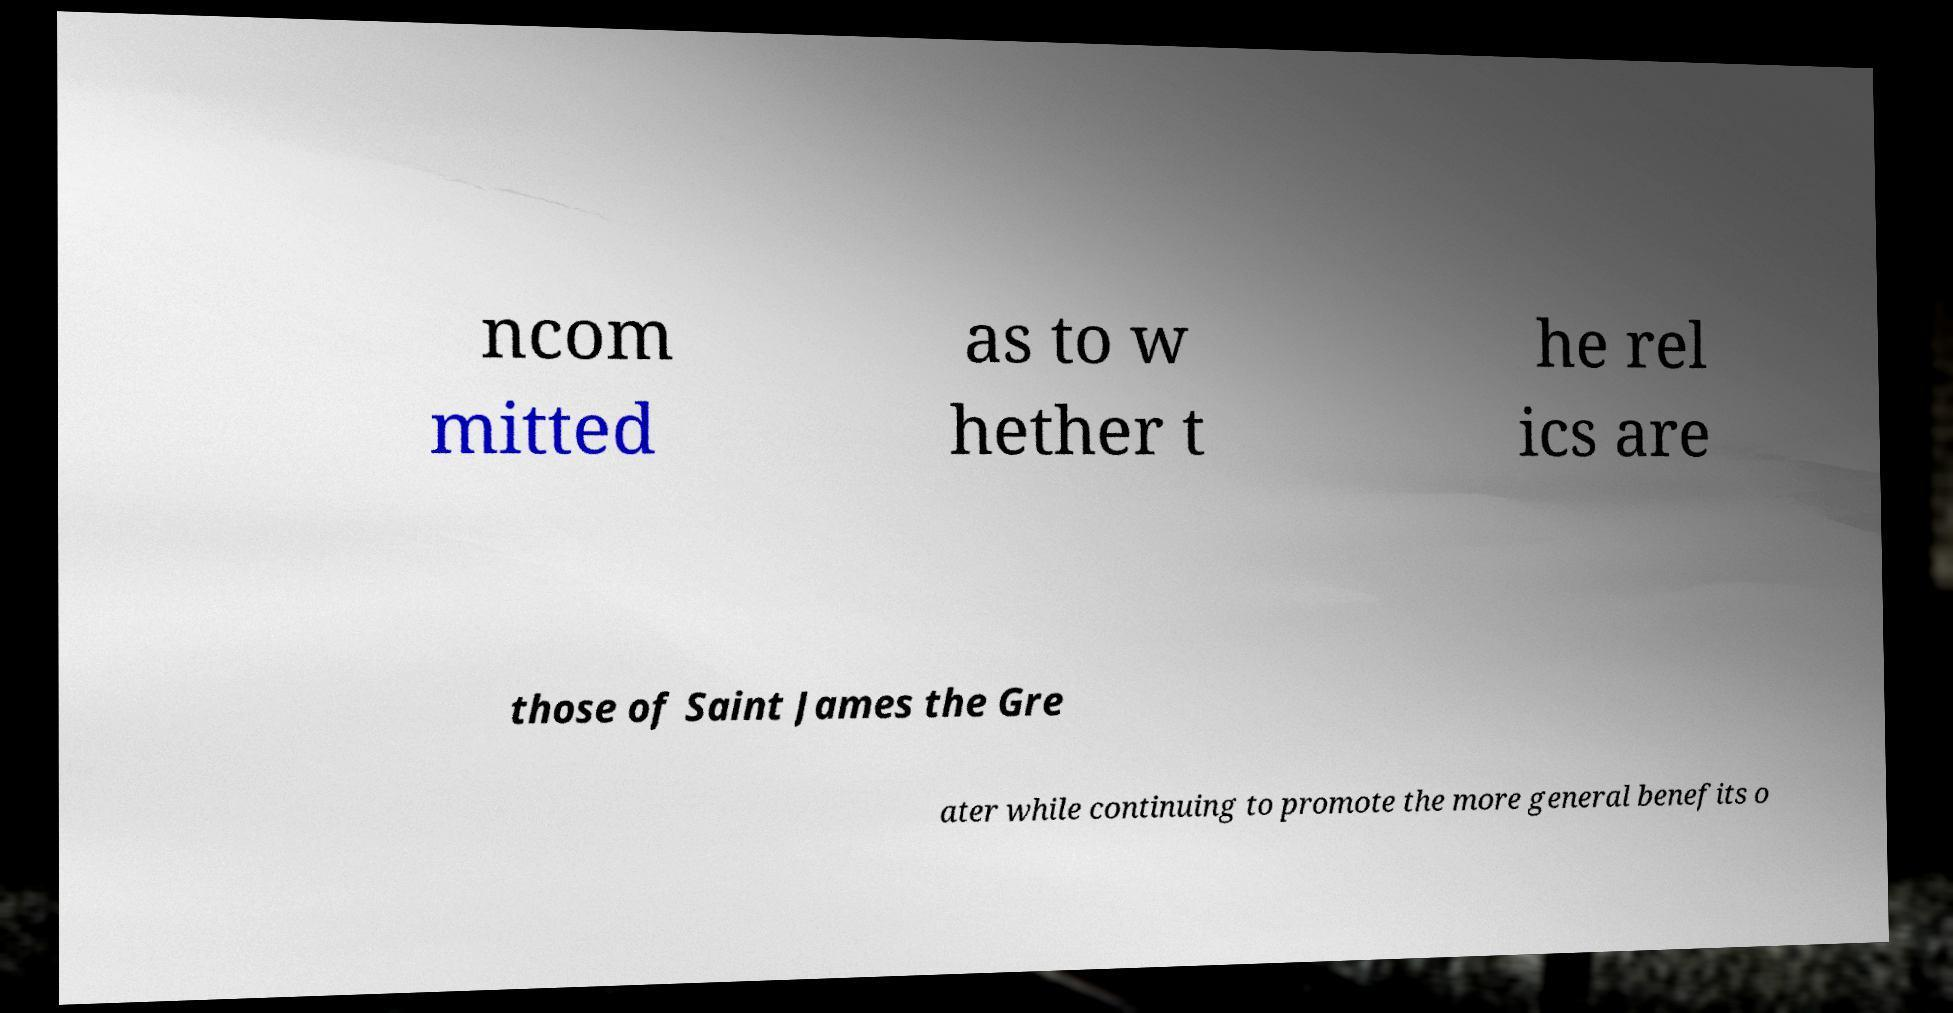Could you assist in decoding the text presented in this image and type it out clearly? ncom mitted as to w hether t he rel ics are those of Saint James the Gre ater while continuing to promote the more general benefits o 